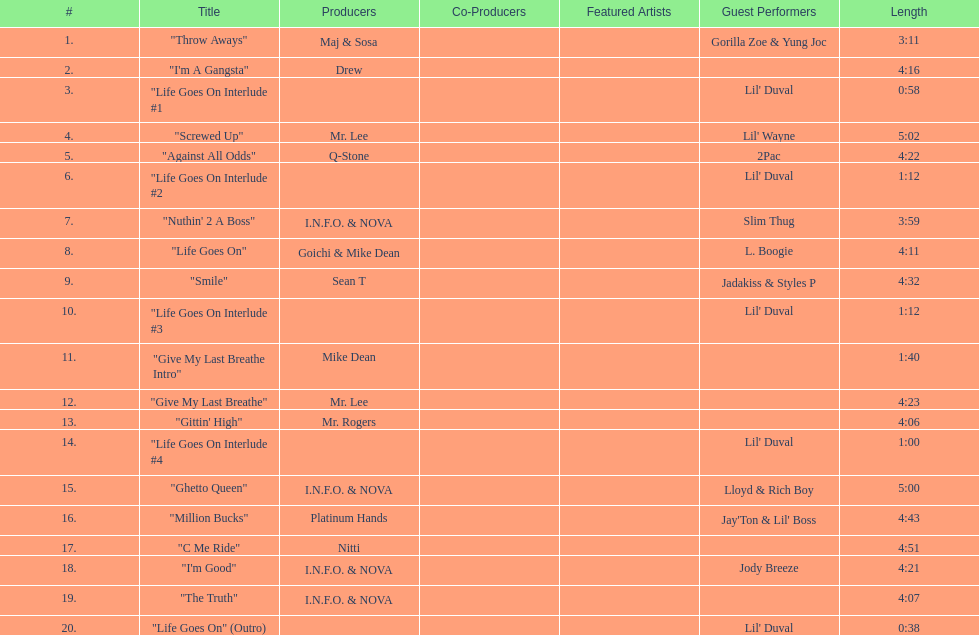Which producers produced the majority of songs on this record? I.N.F.O. & NOVA. 